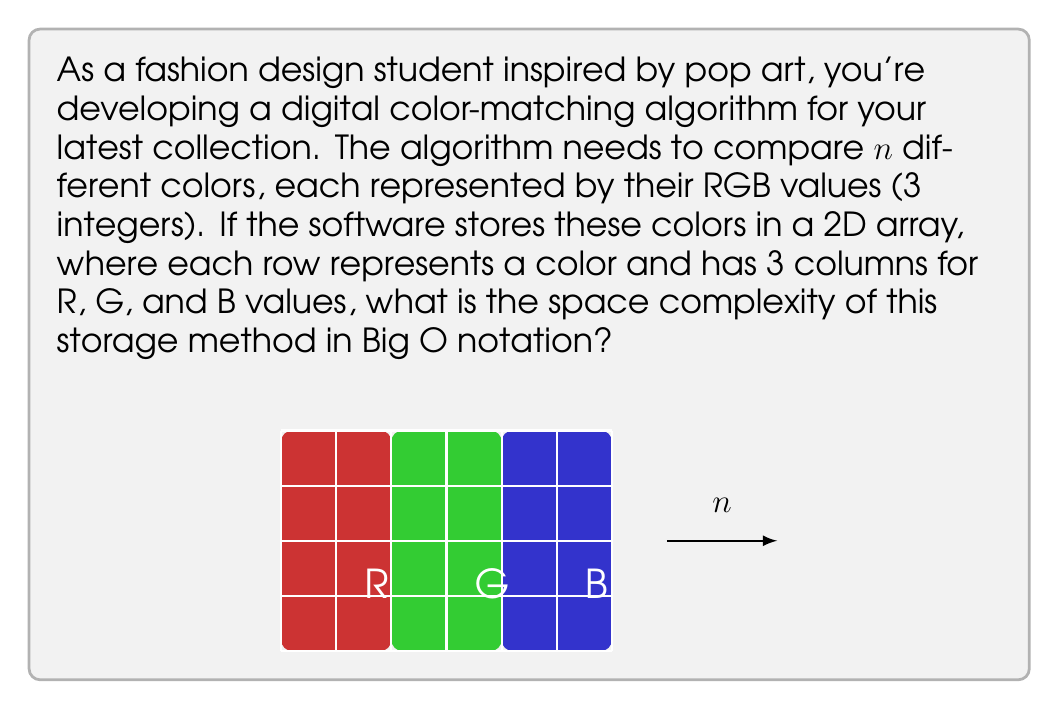Can you answer this question? Let's break this down step-by-step:

1) In the color-matching algorithm, we're storing $n$ colors.

2) Each color is represented by 3 integer values (R, G, B).

3) The storage method is a 2D array, where:
   - The number of rows is $n$ (one for each color)
   - The number of columns is always 3 (for R, G, B)

4) In Big O notation, we're interested in how the space requirements grow as $n$ increases.

5) The total number of elements in the 2D array is:
   $$ \text{Total Elements} = n \times 3 $$

6) Each element is an integer, which typically requires a constant amount of memory (let's call it $c$).

7) So, the total memory used is:
   $$ \text{Total Memory} = n \times 3 \times c $$

8) In Big O notation, we drop constant factors. Both 3 and $c$ are constants, so we can simplify this to:
   $$ O(n) $$

Therefore, the space complexity of this storage method is linear in terms of the number of colors, $n$.
Answer: $O(n)$ 